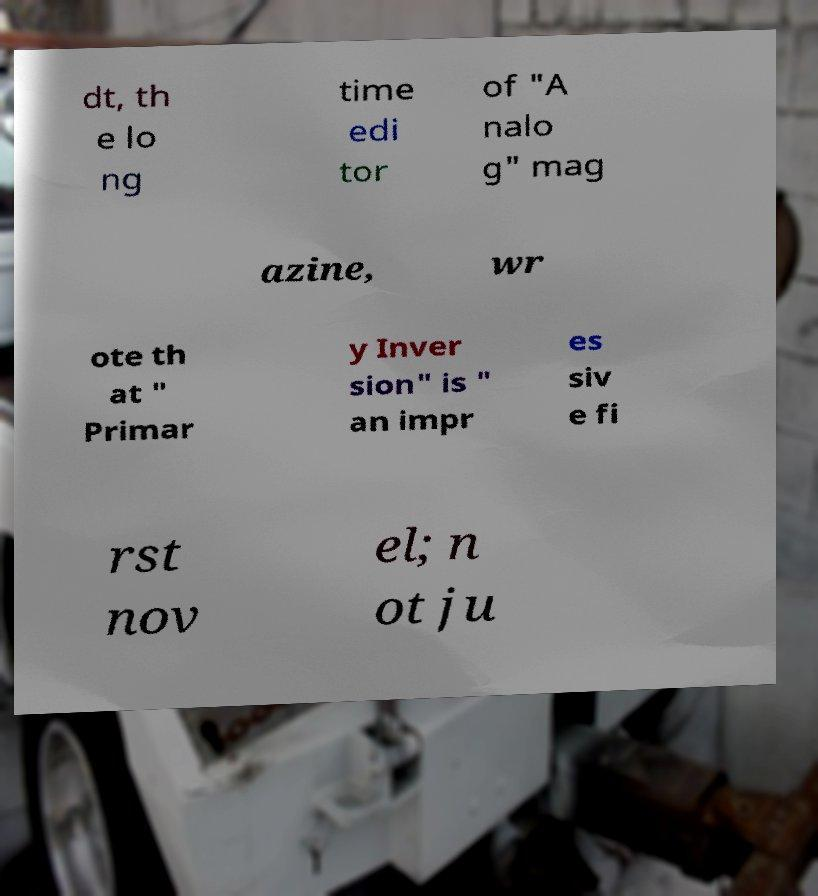What messages or text are displayed in this image? I need them in a readable, typed format. dt, th e lo ng time edi tor of "A nalo g" mag azine, wr ote th at " Primar y Inver sion" is " an impr es siv e fi rst nov el; n ot ju 